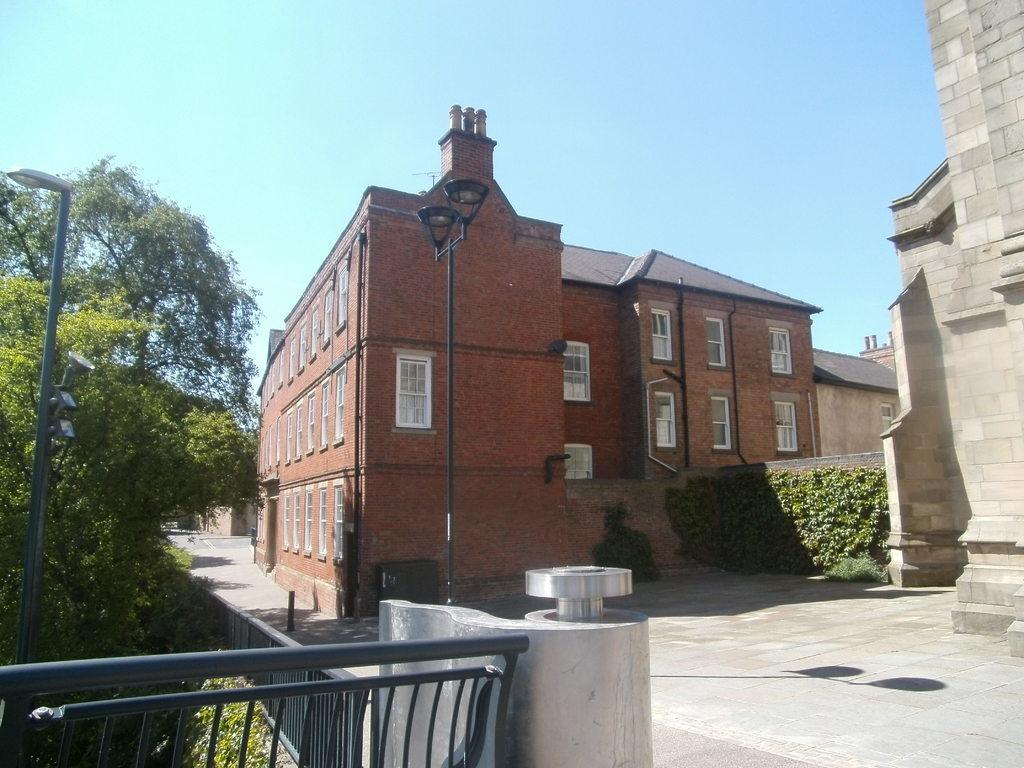Could you give a brief overview of what you see in this image? In the background we can see the sky and it seems like a sunny day. In this picture we can see the buildings, plants, trees, lights, poles, windows. At the bottom portion of the picture we can see the railing. We can see the shadows on the ground. 